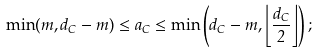<formula> <loc_0><loc_0><loc_500><loc_500>\min ( m , d _ { C } - m ) \leq a _ { C } \leq \min \left ( d _ { C } - m , \left \lfloor \frac { d _ { C } } { 2 } \right \rfloor \right ) ;</formula> 